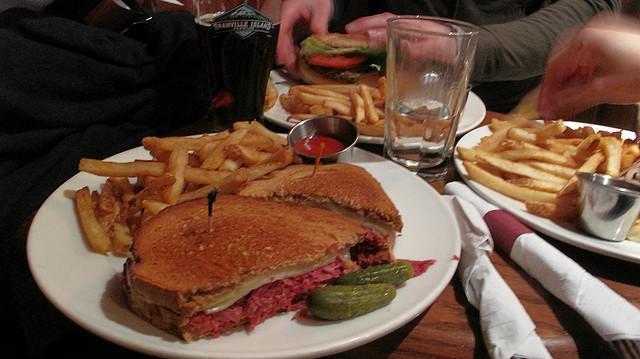How many plates of fries are there?
Give a very brief answer. 3. How many cups can you see?
Give a very brief answer. 2. How many people are visible?
Give a very brief answer. 4. How many sandwiches are there?
Give a very brief answer. 2. How many forks are in the photo?
Give a very brief answer. 1. How many bowls are there?
Give a very brief answer. 2. How many counter sinks are there?
Give a very brief answer. 0. 